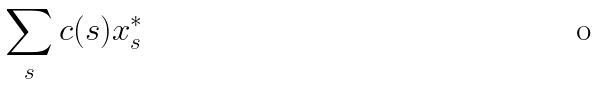Convert formula to latex. <formula><loc_0><loc_0><loc_500><loc_500>\sum _ { s } c ( s ) x _ { s } ^ { * }</formula> 